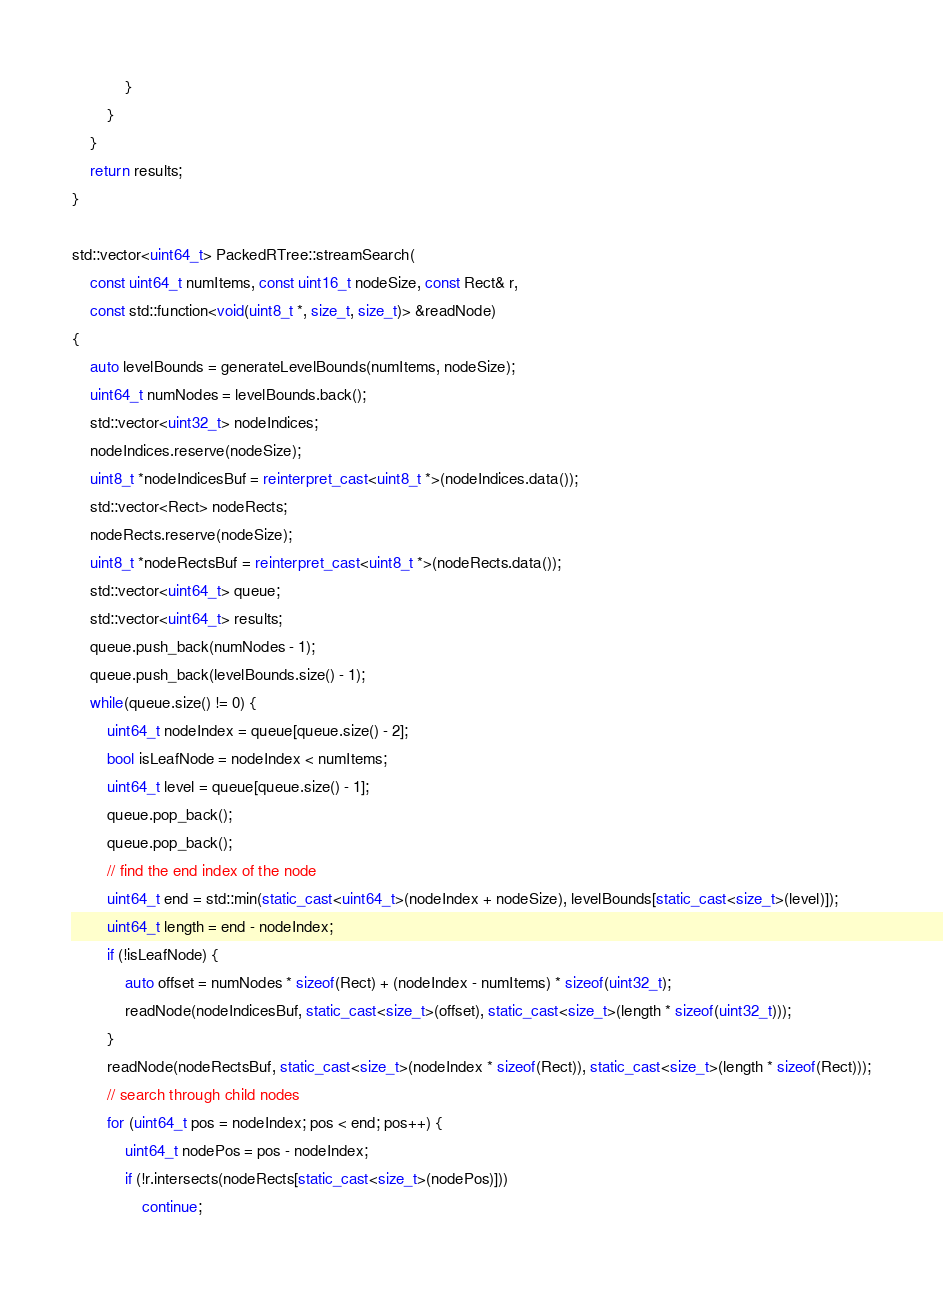<code> <loc_0><loc_0><loc_500><loc_500><_C++_>            }
        }
    }
    return results;
}

std::vector<uint64_t> PackedRTree::streamSearch(
    const uint64_t numItems, const uint16_t nodeSize, const Rect& r,
    const std::function<void(uint8_t *, size_t, size_t)> &readNode)
{
    auto levelBounds = generateLevelBounds(numItems, nodeSize);
    uint64_t numNodes = levelBounds.back();
    std::vector<uint32_t> nodeIndices;
    nodeIndices.reserve(nodeSize);
    uint8_t *nodeIndicesBuf = reinterpret_cast<uint8_t *>(nodeIndices.data());
    std::vector<Rect> nodeRects;
    nodeRects.reserve(nodeSize);
    uint8_t *nodeRectsBuf = reinterpret_cast<uint8_t *>(nodeRects.data());
    std::vector<uint64_t> queue;
    std::vector<uint64_t> results;
    queue.push_back(numNodes - 1);
    queue.push_back(levelBounds.size() - 1);
    while(queue.size() != 0) {
        uint64_t nodeIndex = queue[queue.size() - 2];
        bool isLeafNode = nodeIndex < numItems;
        uint64_t level = queue[queue.size() - 1];
        queue.pop_back();
        queue.pop_back();
        // find the end index of the node
        uint64_t end = std::min(static_cast<uint64_t>(nodeIndex + nodeSize), levelBounds[static_cast<size_t>(level)]);
        uint64_t length = end - nodeIndex;
        if (!isLeafNode) {
            auto offset = numNodes * sizeof(Rect) + (nodeIndex - numItems) * sizeof(uint32_t);
            readNode(nodeIndicesBuf, static_cast<size_t>(offset), static_cast<size_t>(length * sizeof(uint32_t)));
        }
        readNode(nodeRectsBuf, static_cast<size_t>(nodeIndex * sizeof(Rect)), static_cast<size_t>(length * sizeof(Rect)));
        // search through child nodes
        for (uint64_t pos = nodeIndex; pos < end; pos++) {
            uint64_t nodePos = pos - nodeIndex;
            if (!r.intersects(nodeRects[static_cast<size_t>(nodePos)]))
                continue;</code> 